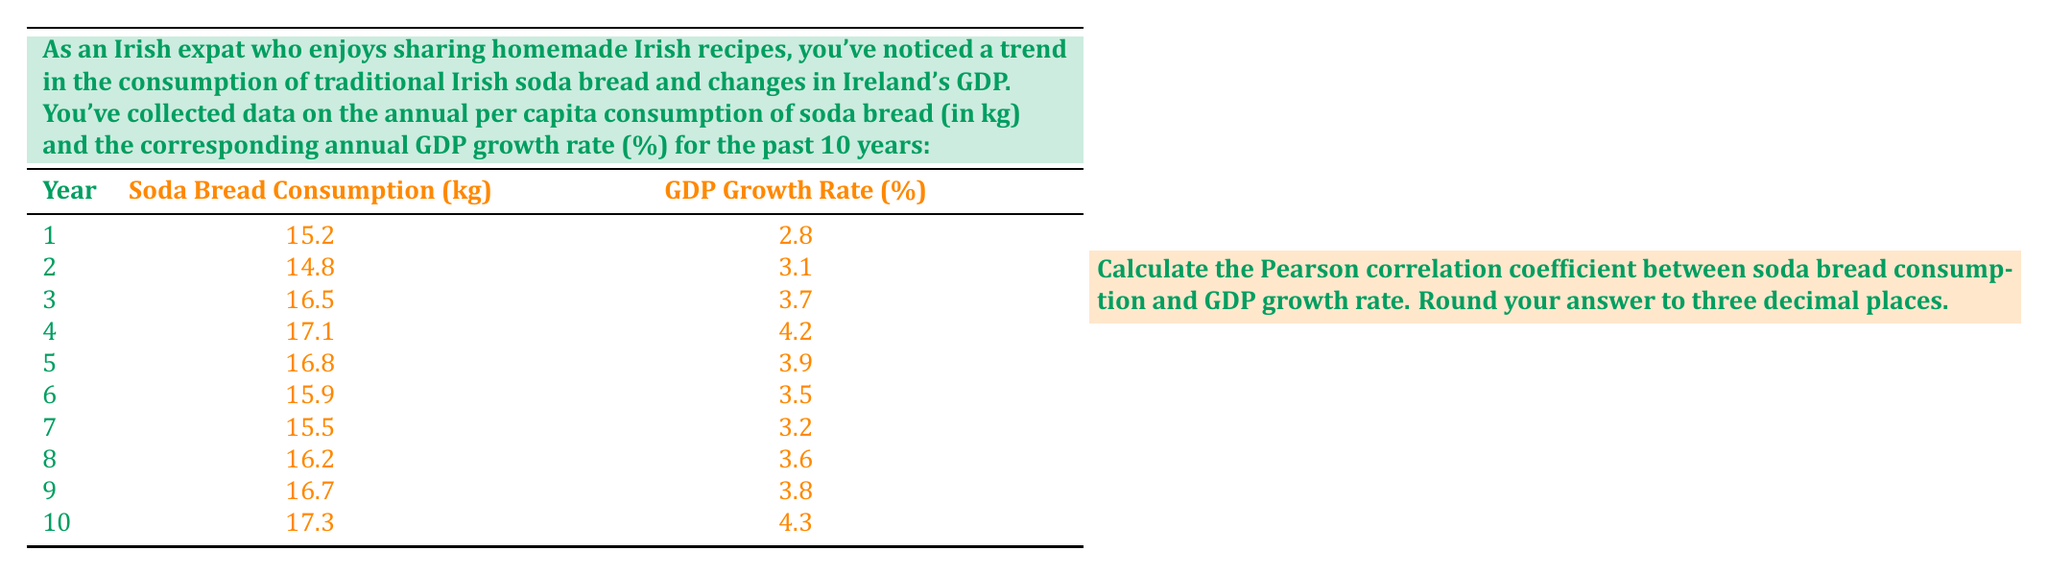What is the answer to this math problem? To calculate the Pearson correlation coefficient, we'll use the formula:

$$r = \frac{\sum_{i=1}^{n} (x_i - \bar{x})(y_i - \bar{y})}{\sqrt{\sum_{i=1}^{n} (x_i - \bar{x})^2 \sum_{i=1}^{n} (y_i - \bar{y})^2}}$$

Where:
$x_i$ = Soda bread consumption values
$y_i$ = GDP growth rate values
$\bar{x}$ = Mean of soda bread consumption
$\bar{y}$ = Mean of GDP growth rate
$n$ = Number of data points (10 in this case)

Step 1: Calculate the means
$\bar{x} = \frac{15.2 + 14.8 + 16.5 + 17.1 + 16.8 + 15.9 + 15.5 + 16.2 + 16.7 + 17.3}{10} = 16.2$
$\bar{y} = \frac{2.8 + 3.1 + 3.7 + 4.2 + 3.9 + 3.5 + 3.2 + 3.6 + 3.8 + 4.3}{10} = 3.61$

Step 2: Calculate $(x_i - \bar{x})$, $(y_i - \bar{y})$, $(x_i - \bar{x})^2$, $(y_i - \bar{y})^2$, and $(x_i - \bar{x})(y_i - \bar{y})$ for each data point.

Step 3: Sum up the values calculated in Step 2:
$\sum (x_i - \bar{x})(y_i - \bar{y}) = 3.185$
$\sum (x_i - \bar{x})^2 = 7.66$
$\sum (y_i - \bar{y})^2 = 2.089$

Step 4: Apply the formula:

$$r = \frac{3.185}{\sqrt{7.66 \times 2.089}} = \frac{3.185}{\sqrt{16.00174}} = \frac{3.185}{4.000217} = 0.796$$

Step 5: Round to three decimal places: 0.796
Answer: 0.796 